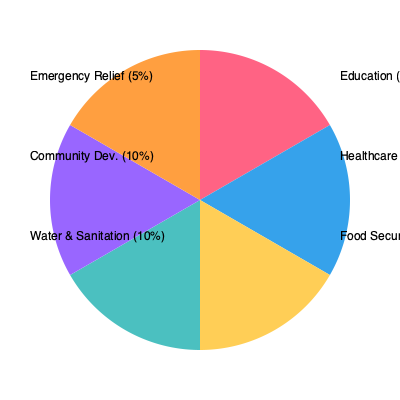Based on the pie chart showing the allocation of resources across various NGO programs, which two programs combined account for 55% of the total resources, and what strategic insight can be drawn from this allocation? To answer this question, we need to follow these steps:

1. Identify the two largest program allocations:
   - Education: 30%
   - Healthcare: 25%

2. Calculate the sum of these two allocations:
   $30\% + 25\% = 55\%$

3. Verify that no other combination of two programs equals 55%.

4. Consider the strategic insight:
   - The majority of resources (55%) are allocated to Education and Healthcare.
   - This suggests a focus on long-term human development and well-being.
   - Education can lead to better job prospects and economic growth.
   - Healthcare improves overall population health and productivity.
   - The combination addresses two fundamental aspects of human development.

5. Contrast with other allocations:
   - Food Security (20%) is the next largest, addressing immediate needs.
   - Water & Sanitation and Community Development (10% each) support infrastructure.
   - Emergency Relief (5%) has the smallest allocation, possibly for unexpected crises.

6. Strategic insight:
   The NGO prioritizes long-term development (Education and Healthcare) while maintaining support for immediate needs and infrastructure, with a small reserve for emergencies.
Answer: Education and Healthcare (55%); prioritizes long-term human development. 